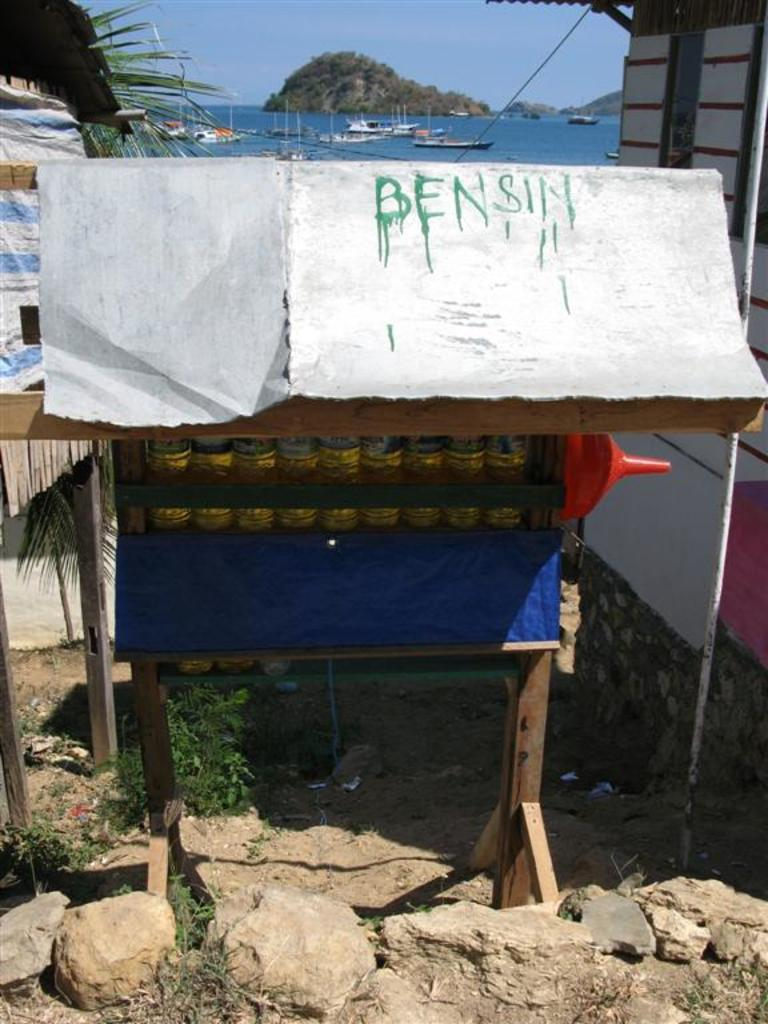What is the setting of the image? The image has an outside view. What can be seen in the middle of the image? There is a rack in the middle of the image. What is on the rack? The rack contains some bottles. What natural feature can be seen in the image? There is sea visible in the image. What is visible at the top of the image? The sky is visible at the top of the image. What type of insurance policy is being discussed by the frogs in the image? There are no frogs present in the image, and therefore no discussion about insurance policies can be observed. How does the profit from the sea affect the rack in the image? There is no mention of profit in the image, and the rack's contents are unaffected by any external factors. 